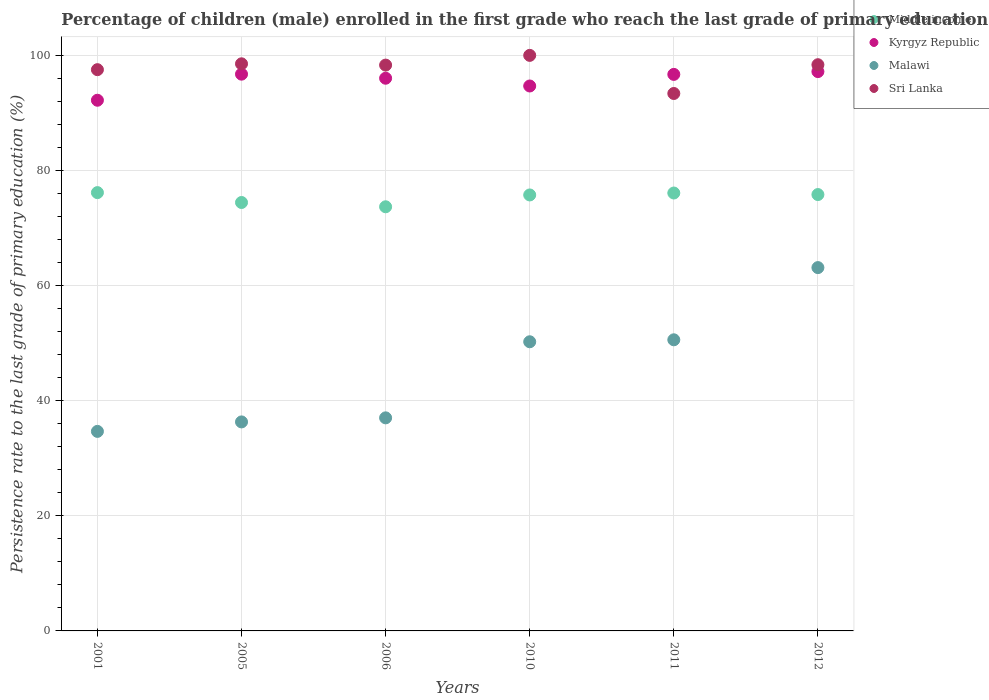Is the number of dotlines equal to the number of legend labels?
Offer a very short reply. Yes. What is the persistence rate of children in Malawi in 2001?
Offer a terse response. 34.67. Across all years, what is the minimum persistence rate of children in Kyrgyz Republic?
Your answer should be very brief. 92.2. In which year was the persistence rate of children in Malawi minimum?
Give a very brief answer. 2001. What is the total persistence rate of children in Middle income in the graph?
Keep it short and to the point. 451.94. What is the difference between the persistence rate of children in Malawi in 2011 and that in 2012?
Give a very brief answer. -12.54. What is the difference between the persistence rate of children in Middle income in 2011 and the persistence rate of children in Malawi in 2012?
Offer a terse response. 12.96. What is the average persistence rate of children in Sri Lanka per year?
Make the answer very short. 97.69. In the year 2001, what is the difference between the persistence rate of children in Kyrgyz Republic and persistence rate of children in Sri Lanka?
Your response must be concise. -5.31. In how many years, is the persistence rate of children in Kyrgyz Republic greater than 96 %?
Your answer should be compact. 4. What is the ratio of the persistence rate of children in Sri Lanka in 2005 to that in 2012?
Keep it short and to the point. 1. Is the persistence rate of children in Malawi in 2006 less than that in 2011?
Your answer should be compact. Yes. Is the difference between the persistence rate of children in Kyrgyz Republic in 2011 and 2012 greater than the difference between the persistence rate of children in Sri Lanka in 2011 and 2012?
Ensure brevity in your answer.  Yes. What is the difference between the highest and the second highest persistence rate of children in Middle income?
Offer a very short reply. 0.07. What is the difference between the highest and the lowest persistence rate of children in Middle income?
Keep it short and to the point. 2.46. In how many years, is the persistence rate of children in Malawi greater than the average persistence rate of children in Malawi taken over all years?
Provide a short and direct response. 3. Is it the case that in every year, the sum of the persistence rate of children in Malawi and persistence rate of children in Sri Lanka  is greater than the sum of persistence rate of children in Middle income and persistence rate of children in Kyrgyz Republic?
Give a very brief answer. No. Does the persistence rate of children in Middle income monotonically increase over the years?
Keep it short and to the point. No. Is the persistence rate of children in Kyrgyz Republic strictly greater than the persistence rate of children in Sri Lanka over the years?
Your answer should be compact. No. How many years are there in the graph?
Make the answer very short. 6. What is the difference between two consecutive major ticks on the Y-axis?
Your answer should be very brief. 20. Does the graph contain any zero values?
Provide a short and direct response. No. Where does the legend appear in the graph?
Your response must be concise. Top right. What is the title of the graph?
Your response must be concise. Percentage of children (male) enrolled in the first grade who reach the last grade of primary education. What is the label or title of the Y-axis?
Your answer should be compact. Persistence rate to the last grade of primary education (%). What is the Persistence rate to the last grade of primary education (%) of Middle income in 2001?
Your response must be concise. 76.16. What is the Persistence rate to the last grade of primary education (%) of Kyrgyz Republic in 2001?
Offer a terse response. 92.2. What is the Persistence rate to the last grade of primary education (%) in Malawi in 2001?
Your answer should be compact. 34.67. What is the Persistence rate to the last grade of primary education (%) of Sri Lanka in 2001?
Provide a succinct answer. 97.52. What is the Persistence rate to the last grade of primary education (%) of Middle income in 2005?
Your answer should be very brief. 74.44. What is the Persistence rate to the last grade of primary education (%) of Kyrgyz Republic in 2005?
Your response must be concise. 96.74. What is the Persistence rate to the last grade of primary education (%) of Malawi in 2005?
Your answer should be compact. 36.31. What is the Persistence rate to the last grade of primary education (%) in Sri Lanka in 2005?
Keep it short and to the point. 98.53. What is the Persistence rate to the last grade of primary education (%) in Middle income in 2006?
Ensure brevity in your answer.  73.69. What is the Persistence rate to the last grade of primary education (%) in Kyrgyz Republic in 2006?
Offer a very short reply. 96.03. What is the Persistence rate to the last grade of primary education (%) in Malawi in 2006?
Offer a terse response. 37.02. What is the Persistence rate to the last grade of primary education (%) in Sri Lanka in 2006?
Your answer should be compact. 98.31. What is the Persistence rate to the last grade of primary education (%) of Middle income in 2010?
Provide a succinct answer. 75.75. What is the Persistence rate to the last grade of primary education (%) in Kyrgyz Republic in 2010?
Keep it short and to the point. 94.68. What is the Persistence rate to the last grade of primary education (%) of Malawi in 2010?
Offer a terse response. 50.24. What is the Persistence rate to the last grade of primary education (%) in Middle income in 2011?
Your response must be concise. 76.09. What is the Persistence rate to the last grade of primary education (%) of Kyrgyz Republic in 2011?
Provide a short and direct response. 96.7. What is the Persistence rate to the last grade of primary education (%) in Malawi in 2011?
Offer a very short reply. 50.58. What is the Persistence rate to the last grade of primary education (%) of Sri Lanka in 2011?
Make the answer very short. 93.38. What is the Persistence rate to the last grade of primary education (%) of Middle income in 2012?
Your response must be concise. 75.82. What is the Persistence rate to the last grade of primary education (%) of Kyrgyz Republic in 2012?
Make the answer very short. 97.18. What is the Persistence rate to the last grade of primary education (%) of Malawi in 2012?
Provide a short and direct response. 63.13. What is the Persistence rate to the last grade of primary education (%) of Sri Lanka in 2012?
Offer a very short reply. 98.38. Across all years, what is the maximum Persistence rate to the last grade of primary education (%) of Middle income?
Your response must be concise. 76.16. Across all years, what is the maximum Persistence rate to the last grade of primary education (%) in Kyrgyz Republic?
Provide a succinct answer. 97.18. Across all years, what is the maximum Persistence rate to the last grade of primary education (%) in Malawi?
Offer a terse response. 63.13. Across all years, what is the maximum Persistence rate to the last grade of primary education (%) in Sri Lanka?
Give a very brief answer. 100. Across all years, what is the minimum Persistence rate to the last grade of primary education (%) in Middle income?
Your answer should be very brief. 73.69. Across all years, what is the minimum Persistence rate to the last grade of primary education (%) of Kyrgyz Republic?
Your answer should be compact. 92.2. Across all years, what is the minimum Persistence rate to the last grade of primary education (%) in Malawi?
Ensure brevity in your answer.  34.67. Across all years, what is the minimum Persistence rate to the last grade of primary education (%) in Sri Lanka?
Provide a succinct answer. 93.38. What is the total Persistence rate to the last grade of primary education (%) of Middle income in the graph?
Provide a succinct answer. 451.94. What is the total Persistence rate to the last grade of primary education (%) in Kyrgyz Republic in the graph?
Give a very brief answer. 573.53. What is the total Persistence rate to the last grade of primary education (%) in Malawi in the graph?
Make the answer very short. 271.95. What is the total Persistence rate to the last grade of primary education (%) of Sri Lanka in the graph?
Your answer should be compact. 586.12. What is the difference between the Persistence rate to the last grade of primary education (%) of Middle income in 2001 and that in 2005?
Provide a short and direct response. 1.72. What is the difference between the Persistence rate to the last grade of primary education (%) in Kyrgyz Republic in 2001 and that in 2005?
Your answer should be compact. -4.53. What is the difference between the Persistence rate to the last grade of primary education (%) of Malawi in 2001 and that in 2005?
Give a very brief answer. -1.64. What is the difference between the Persistence rate to the last grade of primary education (%) in Sri Lanka in 2001 and that in 2005?
Keep it short and to the point. -1.02. What is the difference between the Persistence rate to the last grade of primary education (%) in Middle income in 2001 and that in 2006?
Offer a terse response. 2.46. What is the difference between the Persistence rate to the last grade of primary education (%) of Kyrgyz Republic in 2001 and that in 2006?
Provide a short and direct response. -3.82. What is the difference between the Persistence rate to the last grade of primary education (%) in Malawi in 2001 and that in 2006?
Provide a succinct answer. -2.35. What is the difference between the Persistence rate to the last grade of primary education (%) in Sri Lanka in 2001 and that in 2006?
Make the answer very short. -0.79. What is the difference between the Persistence rate to the last grade of primary education (%) in Middle income in 2001 and that in 2010?
Offer a terse response. 0.41. What is the difference between the Persistence rate to the last grade of primary education (%) in Kyrgyz Republic in 2001 and that in 2010?
Ensure brevity in your answer.  -2.48. What is the difference between the Persistence rate to the last grade of primary education (%) in Malawi in 2001 and that in 2010?
Make the answer very short. -15.57. What is the difference between the Persistence rate to the last grade of primary education (%) of Sri Lanka in 2001 and that in 2010?
Offer a very short reply. -2.48. What is the difference between the Persistence rate to the last grade of primary education (%) in Middle income in 2001 and that in 2011?
Your answer should be compact. 0.07. What is the difference between the Persistence rate to the last grade of primary education (%) of Kyrgyz Republic in 2001 and that in 2011?
Provide a short and direct response. -4.49. What is the difference between the Persistence rate to the last grade of primary education (%) of Malawi in 2001 and that in 2011?
Provide a succinct answer. -15.91. What is the difference between the Persistence rate to the last grade of primary education (%) in Sri Lanka in 2001 and that in 2011?
Ensure brevity in your answer.  4.14. What is the difference between the Persistence rate to the last grade of primary education (%) in Middle income in 2001 and that in 2012?
Your response must be concise. 0.34. What is the difference between the Persistence rate to the last grade of primary education (%) in Kyrgyz Republic in 2001 and that in 2012?
Make the answer very short. -4.98. What is the difference between the Persistence rate to the last grade of primary education (%) in Malawi in 2001 and that in 2012?
Your answer should be very brief. -28.46. What is the difference between the Persistence rate to the last grade of primary education (%) of Sri Lanka in 2001 and that in 2012?
Offer a terse response. -0.86. What is the difference between the Persistence rate to the last grade of primary education (%) of Middle income in 2005 and that in 2006?
Make the answer very short. 0.74. What is the difference between the Persistence rate to the last grade of primary education (%) in Kyrgyz Republic in 2005 and that in 2006?
Give a very brief answer. 0.71. What is the difference between the Persistence rate to the last grade of primary education (%) of Malawi in 2005 and that in 2006?
Offer a terse response. -0.71. What is the difference between the Persistence rate to the last grade of primary education (%) in Sri Lanka in 2005 and that in 2006?
Provide a succinct answer. 0.22. What is the difference between the Persistence rate to the last grade of primary education (%) of Middle income in 2005 and that in 2010?
Ensure brevity in your answer.  -1.31. What is the difference between the Persistence rate to the last grade of primary education (%) of Kyrgyz Republic in 2005 and that in 2010?
Your answer should be very brief. 2.06. What is the difference between the Persistence rate to the last grade of primary education (%) of Malawi in 2005 and that in 2010?
Provide a short and direct response. -13.93. What is the difference between the Persistence rate to the last grade of primary education (%) of Sri Lanka in 2005 and that in 2010?
Give a very brief answer. -1.47. What is the difference between the Persistence rate to the last grade of primary education (%) of Middle income in 2005 and that in 2011?
Your response must be concise. -1.65. What is the difference between the Persistence rate to the last grade of primary education (%) in Kyrgyz Republic in 2005 and that in 2011?
Ensure brevity in your answer.  0.04. What is the difference between the Persistence rate to the last grade of primary education (%) in Malawi in 2005 and that in 2011?
Your response must be concise. -14.27. What is the difference between the Persistence rate to the last grade of primary education (%) in Sri Lanka in 2005 and that in 2011?
Offer a very short reply. 5.16. What is the difference between the Persistence rate to the last grade of primary education (%) of Middle income in 2005 and that in 2012?
Offer a very short reply. -1.38. What is the difference between the Persistence rate to the last grade of primary education (%) of Kyrgyz Republic in 2005 and that in 2012?
Your answer should be very brief. -0.45. What is the difference between the Persistence rate to the last grade of primary education (%) in Malawi in 2005 and that in 2012?
Provide a succinct answer. -26.81. What is the difference between the Persistence rate to the last grade of primary education (%) in Sri Lanka in 2005 and that in 2012?
Your answer should be compact. 0.16. What is the difference between the Persistence rate to the last grade of primary education (%) in Middle income in 2006 and that in 2010?
Your response must be concise. -2.06. What is the difference between the Persistence rate to the last grade of primary education (%) in Kyrgyz Republic in 2006 and that in 2010?
Offer a terse response. 1.35. What is the difference between the Persistence rate to the last grade of primary education (%) in Malawi in 2006 and that in 2010?
Provide a succinct answer. -13.22. What is the difference between the Persistence rate to the last grade of primary education (%) of Sri Lanka in 2006 and that in 2010?
Offer a very short reply. -1.69. What is the difference between the Persistence rate to the last grade of primary education (%) in Middle income in 2006 and that in 2011?
Give a very brief answer. -2.39. What is the difference between the Persistence rate to the last grade of primary education (%) in Kyrgyz Republic in 2006 and that in 2011?
Offer a terse response. -0.67. What is the difference between the Persistence rate to the last grade of primary education (%) of Malawi in 2006 and that in 2011?
Ensure brevity in your answer.  -13.56. What is the difference between the Persistence rate to the last grade of primary education (%) in Sri Lanka in 2006 and that in 2011?
Provide a succinct answer. 4.93. What is the difference between the Persistence rate to the last grade of primary education (%) of Middle income in 2006 and that in 2012?
Provide a succinct answer. -2.12. What is the difference between the Persistence rate to the last grade of primary education (%) of Kyrgyz Republic in 2006 and that in 2012?
Your response must be concise. -1.15. What is the difference between the Persistence rate to the last grade of primary education (%) of Malawi in 2006 and that in 2012?
Make the answer very short. -26.11. What is the difference between the Persistence rate to the last grade of primary education (%) in Sri Lanka in 2006 and that in 2012?
Make the answer very short. -0.07. What is the difference between the Persistence rate to the last grade of primary education (%) in Middle income in 2010 and that in 2011?
Ensure brevity in your answer.  -0.34. What is the difference between the Persistence rate to the last grade of primary education (%) in Kyrgyz Republic in 2010 and that in 2011?
Your response must be concise. -2.02. What is the difference between the Persistence rate to the last grade of primary education (%) in Malawi in 2010 and that in 2011?
Ensure brevity in your answer.  -0.34. What is the difference between the Persistence rate to the last grade of primary education (%) in Sri Lanka in 2010 and that in 2011?
Your answer should be very brief. 6.62. What is the difference between the Persistence rate to the last grade of primary education (%) of Middle income in 2010 and that in 2012?
Provide a short and direct response. -0.07. What is the difference between the Persistence rate to the last grade of primary education (%) in Kyrgyz Republic in 2010 and that in 2012?
Provide a succinct answer. -2.5. What is the difference between the Persistence rate to the last grade of primary education (%) of Malawi in 2010 and that in 2012?
Your answer should be very brief. -12.89. What is the difference between the Persistence rate to the last grade of primary education (%) of Sri Lanka in 2010 and that in 2012?
Provide a short and direct response. 1.62. What is the difference between the Persistence rate to the last grade of primary education (%) of Middle income in 2011 and that in 2012?
Offer a terse response. 0.27. What is the difference between the Persistence rate to the last grade of primary education (%) in Kyrgyz Republic in 2011 and that in 2012?
Offer a terse response. -0.49. What is the difference between the Persistence rate to the last grade of primary education (%) in Malawi in 2011 and that in 2012?
Make the answer very short. -12.54. What is the difference between the Persistence rate to the last grade of primary education (%) in Sri Lanka in 2011 and that in 2012?
Your response must be concise. -5. What is the difference between the Persistence rate to the last grade of primary education (%) in Middle income in 2001 and the Persistence rate to the last grade of primary education (%) in Kyrgyz Republic in 2005?
Offer a terse response. -20.58. What is the difference between the Persistence rate to the last grade of primary education (%) of Middle income in 2001 and the Persistence rate to the last grade of primary education (%) of Malawi in 2005?
Give a very brief answer. 39.84. What is the difference between the Persistence rate to the last grade of primary education (%) of Middle income in 2001 and the Persistence rate to the last grade of primary education (%) of Sri Lanka in 2005?
Make the answer very short. -22.38. What is the difference between the Persistence rate to the last grade of primary education (%) in Kyrgyz Republic in 2001 and the Persistence rate to the last grade of primary education (%) in Malawi in 2005?
Provide a short and direct response. 55.89. What is the difference between the Persistence rate to the last grade of primary education (%) of Kyrgyz Republic in 2001 and the Persistence rate to the last grade of primary education (%) of Sri Lanka in 2005?
Your answer should be compact. -6.33. What is the difference between the Persistence rate to the last grade of primary education (%) of Malawi in 2001 and the Persistence rate to the last grade of primary education (%) of Sri Lanka in 2005?
Offer a very short reply. -63.87. What is the difference between the Persistence rate to the last grade of primary education (%) of Middle income in 2001 and the Persistence rate to the last grade of primary education (%) of Kyrgyz Republic in 2006?
Offer a very short reply. -19.87. What is the difference between the Persistence rate to the last grade of primary education (%) of Middle income in 2001 and the Persistence rate to the last grade of primary education (%) of Malawi in 2006?
Your answer should be compact. 39.13. What is the difference between the Persistence rate to the last grade of primary education (%) of Middle income in 2001 and the Persistence rate to the last grade of primary education (%) of Sri Lanka in 2006?
Make the answer very short. -22.16. What is the difference between the Persistence rate to the last grade of primary education (%) of Kyrgyz Republic in 2001 and the Persistence rate to the last grade of primary education (%) of Malawi in 2006?
Your answer should be compact. 55.18. What is the difference between the Persistence rate to the last grade of primary education (%) in Kyrgyz Republic in 2001 and the Persistence rate to the last grade of primary education (%) in Sri Lanka in 2006?
Offer a terse response. -6.11. What is the difference between the Persistence rate to the last grade of primary education (%) in Malawi in 2001 and the Persistence rate to the last grade of primary education (%) in Sri Lanka in 2006?
Give a very brief answer. -63.64. What is the difference between the Persistence rate to the last grade of primary education (%) of Middle income in 2001 and the Persistence rate to the last grade of primary education (%) of Kyrgyz Republic in 2010?
Provide a succinct answer. -18.53. What is the difference between the Persistence rate to the last grade of primary education (%) of Middle income in 2001 and the Persistence rate to the last grade of primary education (%) of Malawi in 2010?
Offer a very short reply. 25.92. What is the difference between the Persistence rate to the last grade of primary education (%) of Middle income in 2001 and the Persistence rate to the last grade of primary education (%) of Sri Lanka in 2010?
Offer a terse response. -23.84. What is the difference between the Persistence rate to the last grade of primary education (%) in Kyrgyz Republic in 2001 and the Persistence rate to the last grade of primary education (%) in Malawi in 2010?
Keep it short and to the point. 41.97. What is the difference between the Persistence rate to the last grade of primary education (%) in Kyrgyz Republic in 2001 and the Persistence rate to the last grade of primary education (%) in Sri Lanka in 2010?
Offer a very short reply. -7.79. What is the difference between the Persistence rate to the last grade of primary education (%) in Malawi in 2001 and the Persistence rate to the last grade of primary education (%) in Sri Lanka in 2010?
Keep it short and to the point. -65.33. What is the difference between the Persistence rate to the last grade of primary education (%) of Middle income in 2001 and the Persistence rate to the last grade of primary education (%) of Kyrgyz Republic in 2011?
Your answer should be very brief. -20.54. What is the difference between the Persistence rate to the last grade of primary education (%) of Middle income in 2001 and the Persistence rate to the last grade of primary education (%) of Malawi in 2011?
Offer a terse response. 25.57. What is the difference between the Persistence rate to the last grade of primary education (%) of Middle income in 2001 and the Persistence rate to the last grade of primary education (%) of Sri Lanka in 2011?
Keep it short and to the point. -17.22. What is the difference between the Persistence rate to the last grade of primary education (%) in Kyrgyz Republic in 2001 and the Persistence rate to the last grade of primary education (%) in Malawi in 2011?
Provide a succinct answer. 41.62. What is the difference between the Persistence rate to the last grade of primary education (%) in Kyrgyz Republic in 2001 and the Persistence rate to the last grade of primary education (%) in Sri Lanka in 2011?
Ensure brevity in your answer.  -1.17. What is the difference between the Persistence rate to the last grade of primary education (%) in Malawi in 2001 and the Persistence rate to the last grade of primary education (%) in Sri Lanka in 2011?
Make the answer very short. -58.71. What is the difference between the Persistence rate to the last grade of primary education (%) in Middle income in 2001 and the Persistence rate to the last grade of primary education (%) in Kyrgyz Republic in 2012?
Offer a very short reply. -21.03. What is the difference between the Persistence rate to the last grade of primary education (%) in Middle income in 2001 and the Persistence rate to the last grade of primary education (%) in Malawi in 2012?
Keep it short and to the point. 13.03. What is the difference between the Persistence rate to the last grade of primary education (%) of Middle income in 2001 and the Persistence rate to the last grade of primary education (%) of Sri Lanka in 2012?
Give a very brief answer. -22.22. What is the difference between the Persistence rate to the last grade of primary education (%) of Kyrgyz Republic in 2001 and the Persistence rate to the last grade of primary education (%) of Malawi in 2012?
Give a very brief answer. 29.08. What is the difference between the Persistence rate to the last grade of primary education (%) of Kyrgyz Republic in 2001 and the Persistence rate to the last grade of primary education (%) of Sri Lanka in 2012?
Provide a succinct answer. -6.17. What is the difference between the Persistence rate to the last grade of primary education (%) of Malawi in 2001 and the Persistence rate to the last grade of primary education (%) of Sri Lanka in 2012?
Give a very brief answer. -63.71. What is the difference between the Persistence rate to the last grade of primary education (%) in Middle income in 2005 and the Persistence rate to the last grade of primary education (%) in Kyrgyz Republic in 2006?
Offer a terse response. -21.59. What is the difference between the Persistence rate to the last grade of primary education (%) of Middle income in 2005 and the Persistence rate to the last grade of primary education (%) of Malawi in 2006?
Give a very brief answer. 37.42. What is the difference between the Persistence rate to the last grade of primary education (%) in Middle income in 2005 and the Persistence rate to the last grade of primary education (%) in Sri Lanka in 2006?
Offer a terse response. -23.87. What is the difference between the Persistence rate to the last grade of primary education (%) in Kyrgyz Republic in 2005 and the Persistence rate to the last grade of primary education (%) in Malawi in 2006?
Provide a succinct answer. 59.72. What is the difference between the Persistence rate to the last grade of primary education (%) of Kyrgyz Republic in 2005 and the Persistence rate to the last grade of primary education (%) of Sri Lanka in 2006?
Keep it short and to the point. -1.57. What is the difference between the Persistence rate to the last grade of primary education (%) of Malawi in 2005 and the Persistence rate to the last grade of primary education (%) of Sri Lanka in 2006?
Your response must be concise. -62. What is the difference between the Persistence rate to the last grade of primary education (%) of Middle income in 2005 and the Persistence rate to the last grade of primary education (%) of Kyrgyz Republic in 2010?
Provide a succinct answer. -20.24. What is the difference between the Persistence rate to the last grade of primary education (%) in Middle income in 2005 and the Persistence rate to the last grade of primary education (%) in Malawi in 2010?
Offer a terse response. 24.2. What is the difference between the Persistence rate to the last grade of primary education (%) of Middle income in 2005 and the Persistence rate to the last grade of primary education (%) of Sri Lanka in 2010?
Offer a very short reply. -25.56. What is the difference between the Persistence rate to the last grade of primary education (%) of Kyrgyz Republic in 2005 and the Persistence rate to the last grade of primary education (%) of Malawi in 2010?
Provide a succinct answer. 46.5. What is the difference between the Persistence rate to the last grade of primary education (%) in Kyrgyz Republic in 2005 and the Persistence rate to the last grade of primary education (%) in Sri Lanka in 2010?
Offer a very short reply. -3.26. What is the difference between the Persistence rate to the last grade of primary education (%) of Malawi in 2005 and the Persistence rate to the last grade of primary education (%) of Sri Lanka in 2010?
Offer a terse response. -63.69. What is the difference between the Persistence rate to the last grade of primary education (%) in Middle income in 2005 and the Persistence rate to the last grade of primary education (%) in Kyrgyz Republic in 2011?
Your answer should be very brief. -22.26. What is the difference between the Persistence rate to the last grade of primary education (%) of Middle income in 2005 and the Persistence rate to the last grade of primary education (%) of Malawi in 2011?
Provide a succinct answer. 23.86. What is the difference between the Persistence rate to the last grade of primary education (%) of Middle income in 2005 and the Persistence rate to the last grade of primary education (%) of Sri Lanka in 2011?
Provide a short and direct response. -18.94. What is the difference between the Persistence rate to the last grade of primary education (%) of Kyrgyz Republic in 2005 and the Persistence rate to the last grade of primary education (%) of Malawi in 2011?
Keep it short and to the point. 46.16. What is the difference between the Persistence rate to the last grade of primary education (%) in Kyrgyz Republic in 2005 and the Persistence rate to the last grade of primary education (%) in Sri Lanka in 2011?
Give a very brief answer. 3.36. What is the difference between the Persistence rate to the last grade of primary education (%) in Malawi in 2005 and the Persistence rate to the last grade of primary education (%) in Sri Lanka in 2011?
Offer a very short reply. -57.06. What is the difference between the Persistence rate to the last grade of primary education (%) in Middle income in 2005 and the Persistence rate to the last grade of primary education (%) in Kyrgyz Republic in 2012?
Provide a succinct answer. -22.74. What is the difference between the Persistence rate to the last grade of primary education (%) in Middle income in 2005 and the Persistence rate to the last grade of primary education (%) in Malawi in 2012?
Provide a succinct answer. 11.31. What is the difference between the Persistence rate to the last grade of primary education (%) in Middle income in 2005 and the Persistence rate to the last grade of primary education (%) in Sri Lanka in 2012?
Your answer should be compact. -23.94. What is the difference between the Persistence rate to the last grade of primary education (%) in Kyrgyz Republic in 2005 and the Persistence rate to the last grade of primary education (%) in Malawi in 2012?
Your answer should be very brief. 33.61. What is the difference between the Persistence rate to the last grade of primary education (%) in Kyrgyz Republic in 2005 and the Persistence rate to the last grade of primary education (%) in Sri Lanka in 2012?
Provide a succinct answer. -1.64. What is the difference between the Persistence rate to the last grade of primary education (%) in Malawi in 2005 and the Persistence rate to the last grade of primary education (%) in Sri Lanka in 2012?
Ensure brevity in your answer.  -62.06. What is the difference between the Persistence rate to the last grade of primary education (%) of Middle income in 2006 and the Persistence rate to the last grade of primary education (%) of Kyrgyz Republic in 2010?
Give a very brief answer. -20.99. What is the difference between the Persistence rate to the last grade of primary education (%) of Middle income in 2006 and the Persistence rate to the last grade of primary education (%) of Malawi in 2010?
Offer a very short reply. 23.45. What is the difference between the Persistence rate to the last grade of primary education (%) of Middle income in 2006 and the Persistence rate to the last grade of primary education (%) of Sri Lanka in 2010?
Ensure brevity in your answer.  -26.31. What is the difference between the Persistence rate to the last grade of primary education (%) of Kyrgyz Republic in 2006 and the Persistence rate to the last grade of primary education (%) of Malawi in 2010?
Offer a very short reply. 45.79. What is the difference between the Persistence rate to the last grade of primary education (%) of Kyrgyz Republic in 2006 and the Persistence rate to the last grade of primary education (%) of Sri Lanka in 2010?
Provide a succinct answer. -3.97. What is the difference between the Persistence rate to the last grade of primary education (%) of Malawi in 2006 and the Persistence rate to the last grade of primary education (%) of Sri Lanka in 2010?
Your answer should be compact. -62.98. What is the difference between the Persistence rate to the last grade of primary education (%) in Middle income in 2006 and the Persistence rate to the last grade of primary education (%) in Kyrgyz Republic in 2011?
Make the answer very short. -23. What is the difference between the Persistence rate to the last grade of primary education (%) of Middle income in 2006 and the Persistence rate to the last grade of primary education (%) of Malawi in 2011?
Make the answer very short. 23.11. What is the difference between the Persistence rate to the last grade of primary education (%) of Middle income in 2006 and the Persistence rate to the last grade of primary education (%) of Sri Lanka in 2011?
Keep it short and to the point. -19.68. What is the difference between the Persistence rate to the last grade of primary education (%) of Kyrgyz Republic in 2006 and the Persistence rate to the last grade of primary education (%) of Malawi in 2011?
Keep it short and to the point. 45.45. What is the difference between the Persistence rate to the last grade of primary education (%) in Kyrgyz Republic in 2006 and the Persistence rate to the last grade of primary education (%) in Sri Lanka in 2011?
Offer a very short reply. 2.65. What is the difference between the Persistence rate to the last grade of primary education (%) of Malawi in 2006 and the Persistence rate to the last grade of primary education (%) of Sri Lanka in 2011?
Your answer should be very brief. -56.36. What is the difference between the Persistence rate to the last grade of primary education (%) of Middle income in 2006 and the Persistence rate to the last grade of primary education (%) of Kyrgyz Republic in 2012?
Provide a short and direct response. -23.49. What is the difference between the Persistence rate to the last grade of primary education (%) in Middle income in 2006 and the Persistence rate to the last grade of primary education (%) in Malawi in 2012?
Give a very brief answer. 10.57. What is the difference between the Persistence rate to the last grade of primary education (%) in Middle income in 2006 and the Persistence rate to the last grade of primary education (%) in Sri Lanka in 2012?
Make the answer very short. -24.68. What is the difference between the Persistence rate to the last grade of primary education (%) of Kyrgyz Republic in 2006 and the Persistence rate to the last grade of primary education (%) of Malawi in 2012?
Give a very brief answer. 32.9. What is the difference between the Persistence rate to the last grade of primary education (%) in Kyrgyz Republic in 2006 and the Persistence rate to the last grade of primary education (%) in Sri Lanka in 2012?
Your response must be concise. -2.35. What is the difference between the Persistence rate to the last grade of primary education (%) of Malawi in 2006 and the Persistence rate to the last grade of primary education (%) of Sri Lanka in 2012?
Offer a terse response. -61.36. What is the difference between the Persistence rate to the last grade of primary education (%) in Middle income in 2010 and the Persistence rate to the last grade of primary education (%) in Kyrgyz Republic in 2011?
Offer a very short reply. -20.95. What is the difference between the Persistence rate to the last grade of primary education (%) of Middle income in 2010 and the Persistence rate to the last grade of primary education (%) of Malawi in 2011?
Your answer should be very brief. 25.17. What is the difference between the Persistence rate to the last grade of primary education (%) in Middle income in 2010 and the Persistence rate to the last grade of primary education (%) in Sri Lanka in 2011?
Ensure brevity in your answer.  -17.63. What is the difference between the Persistence rate to the last grade of primary education (%) of Kyrgyz Republic in 2010 and the Persistence rate to the last grade of primary education (%) of Malawi in 2011?
Make the answer very short. 44.1. What is the difference between the Persistence rate to the last grade of primary education (%) in Kyrgyz Republic in 2010 and the Persistence rate to the last grade of primary education (%) in Sri Lanka in 2011?
Offer a terse response. 1.3. What is the difference between the Persistence rate to the last grade of primary education (%) of Malawi in 2010 and the Persistence rate to the last grade of primary education (%) of Sri Lanka in 2011?
Give a very brief answer. -43.14. What is the difference between the Persistence rate to the last grade of primary education (%) in Middle income in 2010 and the Persistence rate to the last grade of primary education (%) in Kyrgyz Republic in 2012?
Offer a terse response. -21.43. What is the difference between the Persistence rate to the last grade of primary education (%) in Middle income in 2010 and the Persistence rate to the last grade of primary education (%) in Malawi in 2012?
Make the answer very short. 12.62. What is the difference between the Persistence rate to the last grade of primary education (%) in Middle income in 2010 and the Persistence rate to the last grade of primary education (%) in Sri Lanka in 2012?
Your response must be concise. -22.63. What is the difference between the Persistence rate to the last grade of primary education (%) in Kyrgyz Republic in 2010 and the Persistence rate to the last grade of primary education (%) in Malawi in 2012?
Ensure brevity in your answer.  31.55. What is the difference between the Persistence rate to the last grade of primary education (%) of Kyrgyz Republic in 2010 and the Persistence rate to the last grade of primary education (%) of Sri Lanka in 2012?
Offer a very short reply. -3.7. What is the difference between the Persistence rate to the last grade of primary education (%) of Malawi in 2010 and the Persistence rate to the last grade of primary education (%) of Sri Lanka in 2012?
Offer a terse response. -48.14. What is the difference between the Persistence rate to the last grade of primary education (%) in Middle income in 2011 and the Persistence rate to the last grade of primary education (%) in Kyrgyz Republic in 2012?
Keep it short and to the point. -21.1. What is the difference between the Persistence rate to the last grade of primary education (%) of Middle income in 2011 and the Persistence rate to the last grade of primary education (%) of Malawi in 2012?
Keep it short and to the point. 12.96. What is the difference between the Persistence rate to the last grade of primary education (%) in Middle income in 2011 and the Persistence rate to the last grade of primary education (%) in Sri Lanka in 2012?
Ensure brevity in your answer.  -22.29. What is the difference between the Persistence rate to the last grade of primary education (%) in Kyrgyz Republic in 2011 and the Persistence rate to the last grade of primary education (%) in Malawi in 2012?
Give a very brief answer. 33.57. What is the difference between the Persistence rate to the last grade of primary education (%) in Kyrgyz Republic in 2011 and the Persistence rate to the last grade of primary education (%) in Sri Lanka in 2012?
Provide a short and direct response. -1.68. What is the difference between the Persistence rate to the last grade of primary education (%) of Malawi in 2011 and the Persistence rate to the last grade of primary education (%) of Sri Lanka in 2012?
Keep it short and to the point. -47.8. What is the average Persistence rate to the last grade of primary education (%) of Middle income per year?
Your response must be concise. 75.32. What is the average Persistence rate to the last grade of primary education (%) in Kyrgyz Republic per year?
Keep it short and to the point. 95.59. What is the average Persistence rate to the last grade of primary education (%) of Malawi per year?
Make the answer very short. 45.33. What is the average Persistence rate to the last grade of primary education (%) in Sri Lanka per year?
Offer a terse response. 97.69. In the year 2001, what is the difference between the Persistence rate to the last grade of primary education (%) in Middle income and Persistence rate to the last grade of primary education (%) in Kyrgyz Republic?
Make the answer very short. -16.05. In the year 2001, what is the difference between the Persistence rate to the last grade of primary education (%) of Middle income and Persistence rate to the last grade of primary education (%) of Malawi?
Provide a short and direct response. 41.49. In the year 2001, what is the difference between the Persistence rate to the last grade of primary education (%) in Middle income and Persistence rate to the last grade of primary education (%) in Sri Lanka?
Offer a terse response. -21.36. In the year 2001, what is the difference between the Persistence rate to the last grade of primary education (%) of Kyrgyz Republic and Persistence rate to the last grade of primary education (%) of Malawi?
Make the answer very short. 57.54. In the year 2001, what is the difference between the Persistence rate to the last grade of primary education (%) in Kyrgyz Republic and Persistence rate to the last grade of primary education (%) in Sri Lanka?
Provide a short and direct response. -5.31. In the year 2001, what is the difference between the Persistence rate to the last grade of primary education (%) in Malawi and Persistence rate to the last grade of primary education (%) in Sri Lanka?
Your answer should be compact. -62.85. In the year 2005, what is the difference between the Persistence rate to the last grade of primary education (%) of Middle income and Persistence rate to the last grade of primary education (%) of Kyrgyz Republic?
Provide a succinct answer. -22.3. In the year 2005, what is the difference between the Persistence rate to the last grade of primary education (%) in Middle income and Persistence rate to the last grade of primary education (%) in Malawi?
Your answer should be very brief. 38.12. In the year 2005, what is the difference between the Persistence rate to the last grade of primary education (%) of Middle income and Persistence rate to the last grade of primary education (%) of Sri Lanka?
Keep it short and to the point. -24.1. In the year 2005, what is the difference between the Persistence rate to the last grade of primary education (%) in Kyrgyz Republic and Persistence rate to the last grade of primary education (%) in Malawi?
Your answer should be very brief. 60.42. In the year 2005, what is the difference between the Persistence rate to the last grade of primary education (%) of Kyrgyz Republic and Persistence rate to the last grade of primary education (%) of Sri Lanka?
Your response must be concise. -1.8. In the year 2005, what is the difference between the Persistence rate to the last grade of primary education (%) of Malawi and Persistence rate to the last grade of primary education (%) of Sri Lanka?
Your answer should be compact. -62.22. In the year 2006, what is the difference between the Persistence rate to the last grade of primary education (%) in Middle income and Persistence rate to the last grade of primary education (%) in Kyrgyz Republic?
Your response must be concise. -22.34. In the year 2006, what is the difference between the Persistence rate to the last grade of primary education (%) in Middle income and Persistence rate to the last grade of primary education (%) in Malawi?
Provide a succinct answer. 36.67. In the year 2006, what is the difference between the Persistence rate to the last grade of primary education (%) in Middle income and Persistence rate to the last grade of primary education (%) in Sri Lanka?
Ensure brevity in your answer.  -24.62. In the year 2006, what is the difference between the Persistence rate to the last grade of primary education (%) in Kyrgyz Republic and Persistence rate to the last grade of primary education (%) in Malawi?
Offer a terse response. 59.01. In the year 2006, what is the difference between the Persistence rate to the last grade of primary education (%) of Kyrgyz Republic and Persistence rate to the last grade of primary education (%) of Sri Lanka?
Offer a terse response. -2.28. In the year 2006, what is the difference between the Persistence rate to the last grade of primary education (%) in Malawi and Persistence rate to the last grade of primary education (%) in Sri Lanka?
Give a very brief answer. -61.29. In the year 2010, what is the difference between the Persistence rate to the last grade of primary education (%) of Middle income and Persistence rate to the last grade of primary education (%) of Kyrgyz Republic?
Offer a terse response. -18.93. In the year 2010, what is the difference between the Persistence rate to the last grade of primary education (%) of Middle income and Persistence rate to the last grade of primary education (%) of Malawi?
Keep it short and to the point. 25.51. In the year 2010, what is the difference between the Persistence rate to the last grade of primary education (%) of Middle income and Persistence rate to the last grade of primary education (%) of Sri Lanka?
Keep it short and to the point. -24.25. In the year 2010, what is the difference between the Persistence rate to the last grade of primary education (%) of Kyrgyz Republic and Persistence rate to the last grade of primary education (%) of Malawi?
Offer a terse response. 44.44. In the year 2010, what is the difference between the Persistence rate to the last grade of primary education (%) in Kyrgyz Republic and Persistence rate to the last grade of primary education (%) in Sri Lanka?
Ensure brevity in your answer.  -5.32. In the year 2010, what is the difference between the Persistence rate to the last grade of primary education (%) in Malawi and Persistence rate to the last grade of primary education (%) in Sri Lanka?
Provide a succinct answer. -49.76. In the year 2011, what is the difference between the Persistence rate to the last grade of primary education (%) of Middle income and Persistence rate to the last grade of primary education (%) of Kyrgyz Republic?
Provide a short and direct response. -20.61. In the year 2011, what is the difference between the Persistence rate to the last grade of primary education (%) of Middle income and Persistence rate to the last grade of primary education (%) of Malawi?
Provide a short and direct response. 25.5. In the year 2011, what is the difference between the Persistence rate to the last grade of primary education (%) in Middle income and Persistence rate to the last grade of primary education (%) in Sri Lanka?
Provide a succinct answer. -17.29. In the year 2011, what is the difference between the Persistence rate to the last grade of primary education (%) in Kyrgyz Republic and Persistence rate to the last grade of primary education (%) in Malawi?
Offer a terse response. 46.11. In the year 2011, what is the difference between the Persistence rate to the last grade of primary education (%) in Kyrgyz Republic and Persistence rate to the last grade of primary education (%) in Sri Lanka?
Keep it short and to the point. 3.32. In the year 2011, what is the difference between the Persistence rate to the last grade of primary education (%) in Malawi and Persistence rate to the last grade of primary education (%) in Sri Lanka?
Ensure brevity in your answer.  -42.8. In the year 2012, what is the difference between the Persistence rate to the last grade of primary education (%) of Middle income and Persistence rate to the last grade of primary education (%) of Kyrgyz Republic?
Keep it short and to the point. -21.37. In the year 2012, what is the difference between the Persistence rate to the last grade of primary education (%) of Middle income and Persistence rate to the last grade of primary education (%) of Malawi?
Keep it short and to the point. 12.69. In the year 2012, what is the difference between the Persistence rate to the last grade of primary education (%) of Middle income and Persistence rate to the last grade of primary education (%) of Sri Lanka?
Offer a very short reply. -22.56. In the year 2012, what is the difference between the Persistence rate to the last grade of primary education (%) of Kyrgyz Republic and Persistence rate to the last grade of primary education (%) of Malawi?
Provide a short and direct response. 34.06. In the year 2012, what is the difference between the Persistence rate to the last grade of primary education (%) of Kyrgyz Republic and Persistence rate to the last grade of primary education (%) of Sri Lanka?
Provide a succinct answer. -1.2. In the year 2012, what is the difference between the Persistence rate to the last grade of primary education (%) in Malawi and Persistence rate to the last grade of primary education (%) in Sri Lanka?
Your answer should be compact. -35.25. What is the ratio of the Persistence rate to the last grade of primary education (%) of Middle income in 2001 to that in 2005?
Your answer should be compact. 1.02. What is the ratio of the Persistence rate to the last grade of primary education (%) in Kyrgyz Republic in 2001 to that in 2005?
Keep it short and to the point. 0.95. What is the ratio of the Persistence rate to the last grade of primary education (%) in Malawi in 2001 to that in 2005?
Keep it short and to the point. 0.95. What is the ratio of the Persistence rate to the last grade of primary education (%) of Sri Lanka in 2001 to that in 2005?
Your response must be concise. 0.99. What is the ratio of the Persistence rate to the last grade of primary education (%) of Middle income in 2001 to that in 2006?
Offer a very short reply. 1.03. What is the ratio of the Persistence rate to the last grade of primary education (%) of Kyrgyz Republic in 2001 to that in 2006?
Keep it short and to the point. 0.96. What is the ratio of the Persistence rate to the last grade of primary education (%) of Malawi in 2001 to that in 2006?
Ensure brevity in your answer.  0.94. What is the ratio of the Persistence rate to the last grade of primary education (%) of Sri Lanka in 2001 to that in 2006?
Offer a terse response. 0.99. What is the ratio of the Persistence rate to the last grade of primary education (%) of Middle income in 2001 to that in 2010?
Ensure brevity in your answer.  1.01. What is the ratio of the Persistence rate to the last grade of primary education (%) in Kyrgyz Republic in 2001 to that in 2010?
Give a very brief answer. 0.97. What is the ratio of the Persistence rate to the last grade of primary education (%) of Malawi in 2001 to that in 2010?
Offer a terse response. 0.69. What is the ratio of the Persistence rate to the last grade of primary education (%) in Sri Lanka in 2001 to that in 2010?
Give a very brief answer. 0.98. What is the ratio of the Persistence rate to the last grade of primary education (%) of Kyrgyz Republic in 2001 to that in 2011?
Provide a short and direct response. 0.95. What is the ratio of the Persistence rate to the last grade of primary education (%) in Malawi in 2001 to that in 2011?
Ensure brevity in your answer.  0.69. What is the ratio of the Persistence rate to the last grade of primary education (%) in Sri Lanka in 2001 to that in 2011?
Give a very brief answer. 1.04. What is the ratio of the Persistence rate to the last grade of primary education (%) in Middle income in 2001 to that in 2012?
Provide a succinct answer. 1. What is the ratio of the Persistence rate to the last grade of primary education (%) in Kyrgyz Republic in 2001 to that in 2012?
Your answer should be very brief. 0.95. What is the ratio of the Persistence rate to the last grade of primary education (%) in Malawi in 2001 to that in 2012?
Your answer should be compact. 0.55. What is the ratio of the Persistence rate to the last grade of primary education (%) of Middle income in 2005 to that in 2006?
Your answer should be compact. 1.01. What is the ratio of the Persistence rate to the last grade of primary education (%) of Kyrgyz Republic in 2005 to that in 2006?
Offer a terse response. 1.01. What is the ratio of the Persistence rate to the last grade of primary education (%) in Malawi in 2005 to that in 2006?
Offer a terse response. 0.98. What is the ratio of the Persistence rate to the last grade of primary education (%) of Middle income in 2005 to that in 2010?
Provide a short and direct response. 0.98. What is the ratio of the Persistence rate to the last grade of primary education (%) of Kyrgyz Republic in 2005 to that in 2010?
Provide a succinct answer. 1.02. What is the ratio of the Persistence rate to the last grade of primary education (%) in Malawi in 2005 to that in 2010?
Your answer should be compact. 0.72. What is the ratio of the Persistence rate to the last grade of primary education (%) of Middle income in 2005 to that in 2011?
Give a very brief answer. 0.98. What is the ratio of the Persistence rate to the last grade of primary education (%) in Malawi in 2005 to that in 2011?
Your answer should be very brief. 0.72. What is the ratio of the Persistence rate to the last grade of primary education (%) in Sri Lanka in 2005 to that in 2011?
Ensure brevity in your answer.  1.06. What is the ratio of the Persistence rate to the last grade of primary education (%) in Middle income in 2005 to that in 2012?
Make the answer very short. 0.98. What is the ratio of the Persistence rate to the last grade of primary education (%) of Kyrgyz Republic in 2005 to that in 2012?
Your answer should be compact. 1. What is the ratio of the Persistence rate to the last grade of primary education (%) of Malawi in 2005 to that in 2012?
Provide a succinct answer. 0.58. What is the ratio of the Persistence rate to the last grade of primary education (%) of Sri Lanka in 2005 to that in 2012?
Keep it short and to the point. 1. What is the ratio of the Persistence rate to the last grade of primary education (%) in Middle income in 2006 to that in 2010?
Offer a very short reply. 0.97. What is the ratio of the Persistence rate to the last grade of primary education (%) in Kyrgyz Republic in 2006 to that in 2010?
Offer a terse response. 1.01. What is the ratio of the Persistence rate to the last grade of primary education (%) in Malawi in 2006 to that in 2010?
Offer a terse response. 0.74. What is the ratio of the Persistence rate to the last grade of primary education (%) of Sri Lanka in 2006 to that in 2010?
Provide a succinct answer. 0.98. What is the ratio of the Persistence rate to the last grade of primary education (%) in Middle income in 2006 to that in 2011?
Provide a succinct answer. 0.97. What is the ratio of the Persistence rate to the last grade of primary education (%) in Malawi in 2006 to that in 2011?
Your answer should be very brief. 0.73. What is the ratio of the Persistence rate to the last grade of primary education (%) of Sri Lanka in 2006 to that in 2011?
Provide a succinct answer. 1.05. What is the ratio of the Persistence rate to the last grade of primary education (%) in Middle income in 2006 to that in 2012?
Offer a very short reply. 0.97. What is the ratio of the Persistence rate to the last grade of primary education (%) of Kyrgyz Republic in 2006 to that in 2012?
Provide a succinct answer. 0.99. What is the ratio of the Persistence rate to the last grade of primary education (%) of Malawi in 2006 to that in 2012?
Give a very brief answer. 0.59. What is the ratio of the Persistence rate to the last grade of primary education (%) of Kyrgyz Republic in 2010 to that in 2011?
Your response must be concise. 0.98. What is the ratio of the Persistence rate to the last grade of primary education (%) in Sri Lanka in 2010 to that in 2011?
Ensure brevity in your answer.  1.07. What is the ratio of the Persistence rate to the last grade of primary education (%) in Kyrgyz Republic in 2010 to that in 2012?
Offer a very short reply. 0.97. What is the ratio of the Persistence rate to the last grade of primary education (%) of Malawi in 2010 to that in 2012?
Offer a very short reply. 0.8. What is the ratio of the Persistence rate to the last grade of primary education (%) in Sri Lanka in 2010 to that in 2012?
Ensure brevity in your answer.  1.02. What is the ratio of the Persistence rate to the last grade of primary education (%) in Malawi in 2011 to that in 2012?
Provide a short and direct response. 0.8. What is the ratio of the Persistence rate to the last grade of primary education (%) in Sri Lanka in 2011 to that in 2012?
Your response must be concise. 0.95. What is the difference between the highest and the second highest Persistence rate to the last grade of primary education (%) in Middle income?
Make the answer very short. 0.07. What is the difference between the highest and the second highest Persistence rate to the last grade of primary education (%) in Kyrgyz Republic?
Make the answer very short. 0.45. What is the difference between the highest and the second highest Persistence rate to the last grade of primary education (%) in Malawi?
Provide a short and direct response. 12.54. What is the difference between the highest and the second highest Persistence rate to the last grade of primary education (%) in Sri Lanka?
Give a very brief answer. 1.47. What is the difference between the highest and the lowest Persistence rate to the last grade of primary education (%) in Middle income?
Ensure brevity in your answer.  2.46. What is the difference between the highest and the lowest Persistence rate to the last grade of primary education (%) of Kyrgyz Republic?
Make the answer very short. 4.98. What is the difference between the highest and the lowest Persistence rate to the last grade of primary education (%) of Malawi?
Your answer should be very brief. 28.46. What is the difference between the highest and the lowest Persistence rate to the last grade of primary education (%) of Sri Lanka?
Offer a very short reply. 6.62. 